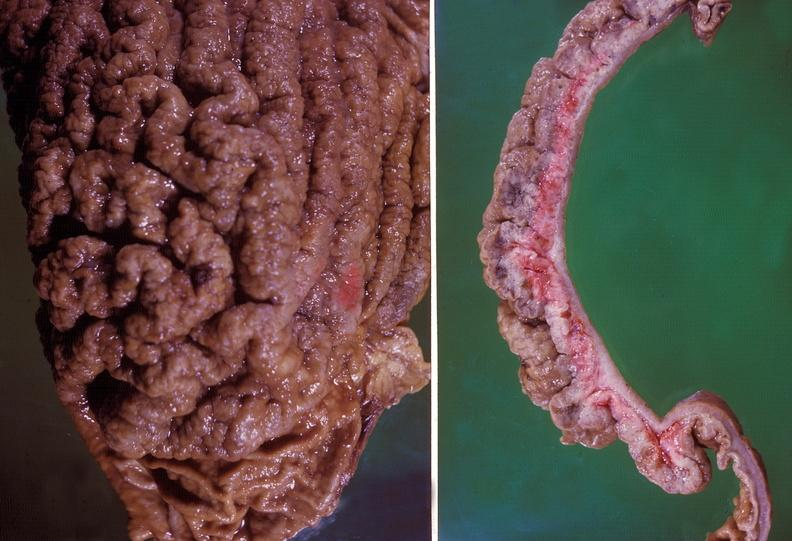does malignant adenoma show stomach, giant rugose hypertrophy?
Answer the question using a single word or phrase. No 